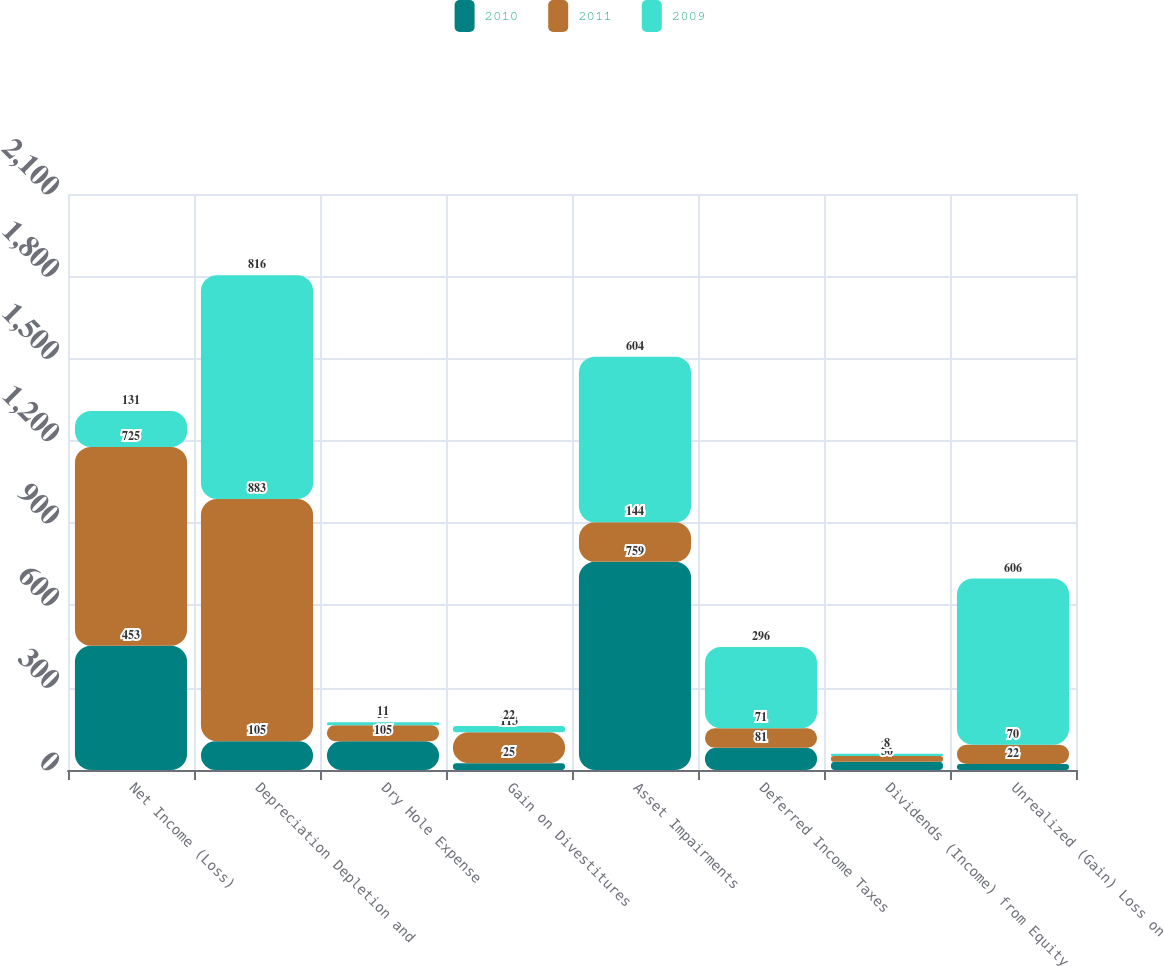<chart> <loc_0><loc_0><loc_500><loc_500><stacked_bar_chart><ecel><fcel>Net Income (Loss)<fcel>Depreciation Depletion and<fcel>Dry Hole Expense<fcel>Gain on Divestitures<fcel>Asset Impairments<fcel>Deferred Income Taxes<fcel>Dividends (Income) from Equity<fcel>Unrealized (Gain) Loss on<nl><fcel>2010<fcel>453<fcel>105<fcel>105<fcel>25<fcel>759<fcel>81<fcel>30<fcel>22<nl><fcel>2011<fcel>725<fcel>883<fcel>58<fcel>113<fcel>144<fcel>71<fcel>21<fcel>70<nl><fcel>2009<fcel>131<fcel>816<fcel>11<fcel>22<fcel>604<fcel>296<fcel>8<fcel>606<nl></chart> 